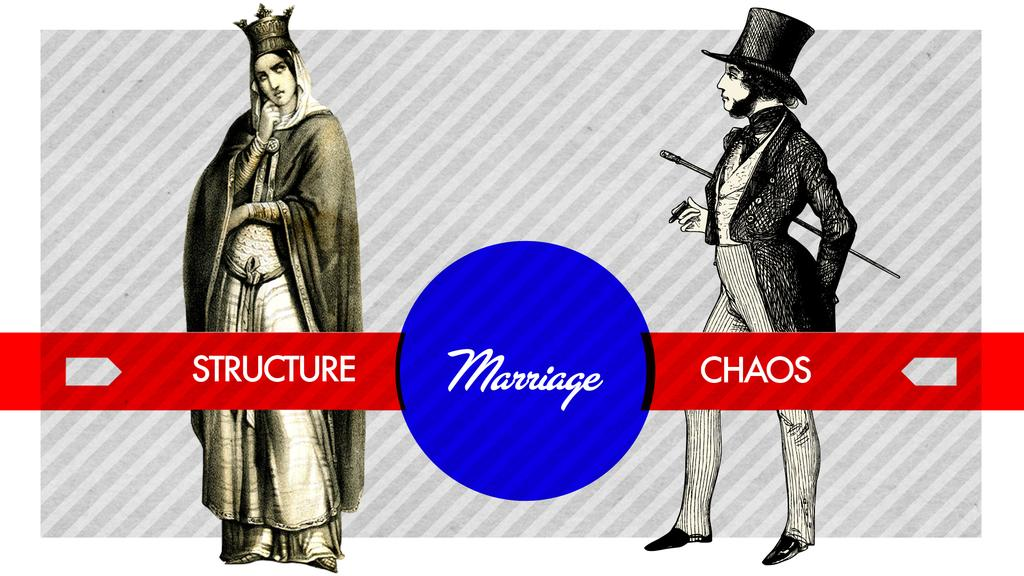What type of picture is in the image? The image contains an edited picture. How many people are in the edited picture? There are two people in the image. Is there any text present in the image? Yes, there is text present in the image. What type of polish is being applied to the arm in the image? There is no arm or polish present in the image; it contains an edited picture of two people with text. 